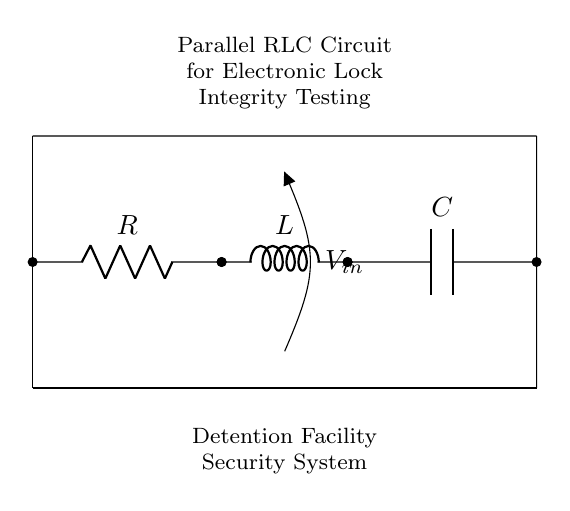What components are in the circuit? The circuit contains a resistor, an inductor, and a capacitor, which are clearly labeled in the diagram.
Answer: Resistor, inductor, capacitor What is the input voltage labeled in the circuit? The diagram shows an input voltage labeled as V-in, which refers to the voltage applied to the circuit.
Answer: V-in What type of circuit is represented in this diagram? The diagram depicts a parallel circuit, as the components are connected alongside each other, sharing the same voltage across all.
Answer: Parallel Which component provides current damping in this circuit? The inductor is responsible for current damping due to its property of opposing changes in current flow, which is a key characteristic in parallel RLC circuits.
Answer: Inductor What effect does increasing the resistance have on the circuit's response? Increasing the resistance will reduce the overall current through the circuit, affecting the damping and possibly changing the resonant frequency, which is crucial for lock integrity testing.
Answer: Reduced current What happens if the capacitance is increased in this circuit? Increasing the capacitance will lower the resonant frequency of the circuit, which can affect the timing characteristics and potentially the performance of the electronic locks being tested.
Answer: Lower resonant frequency 